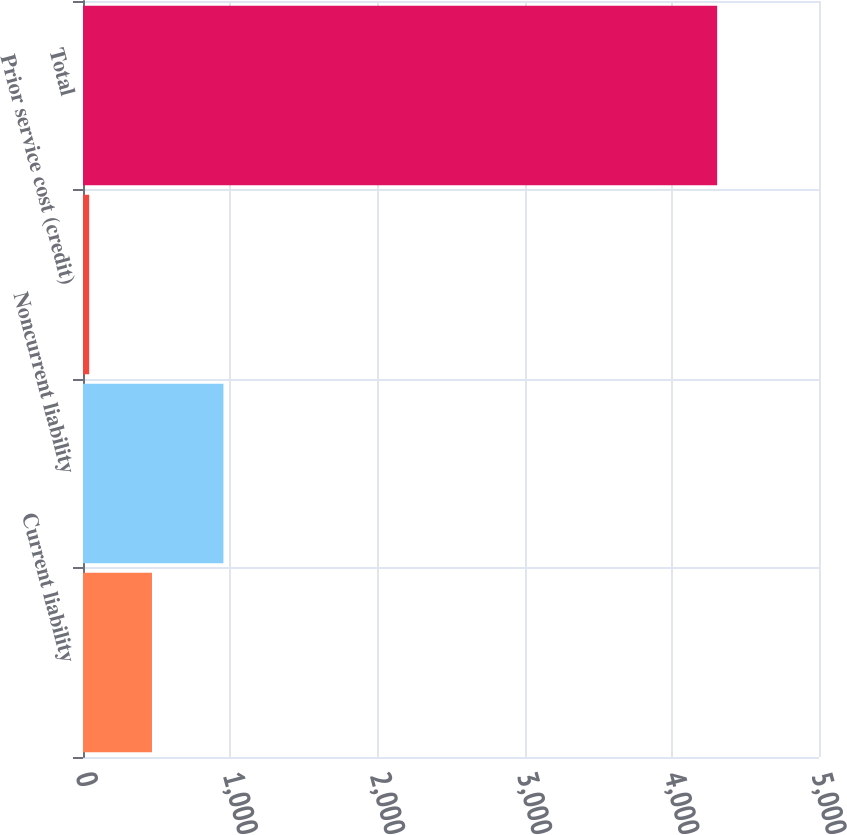Convert chart to OTSL. <chart><loc_0><loc_0><loc_500><loc_500><bar_chart><fcel>Current liability<fcel>Noncurrent liability<fcel>Prior service cost (credit)<fcel>Total<nl><fcel>468.6<fcel>954<fcel>42<fcel>4308<nl></chart> 